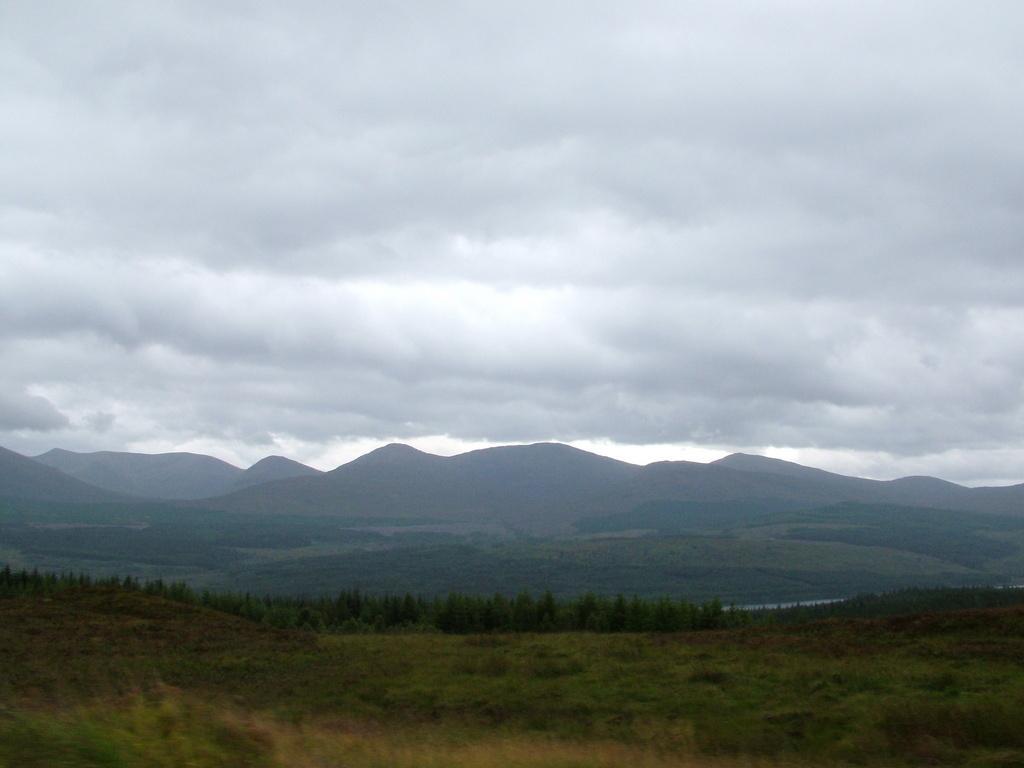In one or two sentences, can you explain what this image depicts? Here in this picture we can see the ground is fully covered with grass, plants and trees all over there and we can also see mountains that are covered with grass and plants and we can see the sky is fully covered with clouds over there. 